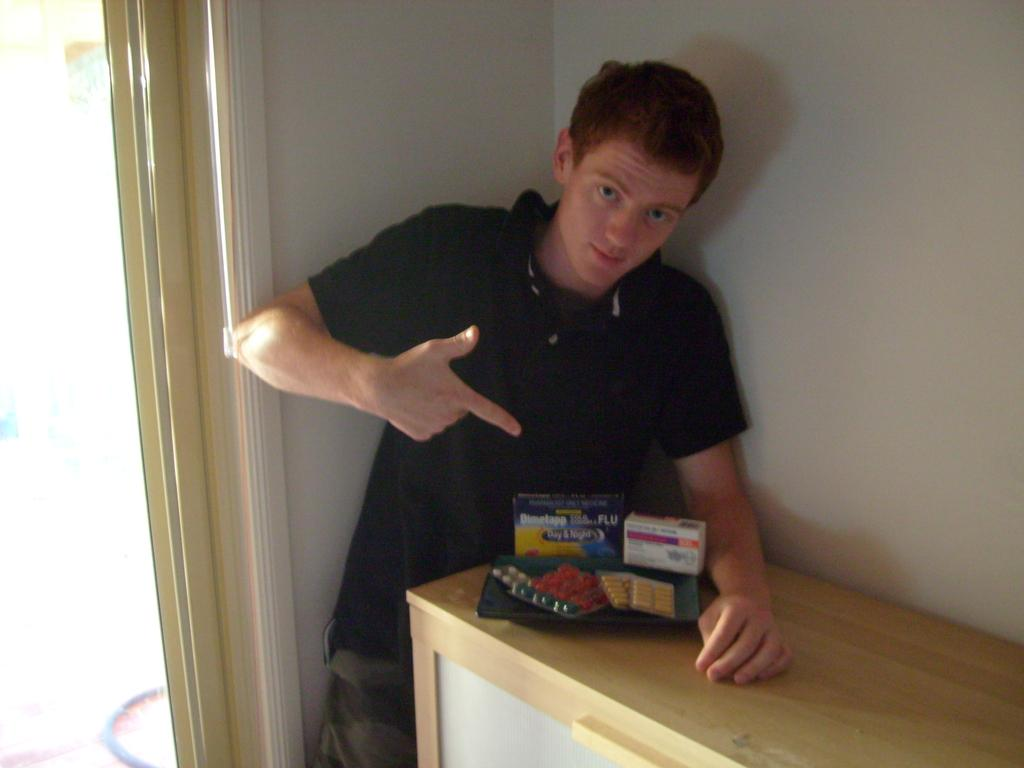Who is present in the image? There is a man in the image. What is the man doing in the image? The man is standing near a wall and pointing towards tablets. What is the man wearing in the image? The man is wearing a black t-shirt. What can be seen on the left side of the image? There is a door on the left side of the image. Can you see a goat walking along a line in the image? There is no goat or line present in the image. Is there a river flowing through the scene in the image? There is no river visible in the image. 